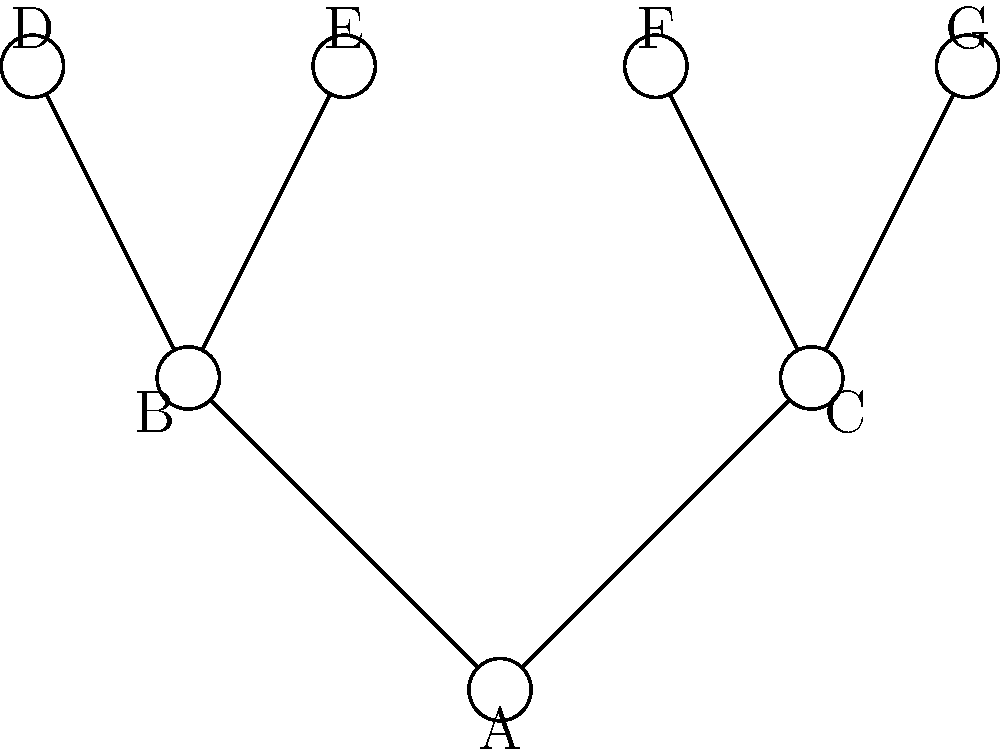In the family tree topology shown above, which represents a simplified genealogical structure, what is the total number of connected components and cycles (loops) present? To answer this question, we need to analyze the topological properties of the given family tree structure:

1. Connected Components:
   - A connected component is a subset of the graph where any two vertices are connected by a path.
   - In this family tree, all nodes (A through G) are connected to each other through edges.
   - Therefore, there is only one connected component.

2. Cycles (Loops):
   - A cycle is a path that starts and ends at the same vertex without repeating any edges.
   - In this family tree structure, there are no cycles present.
   - The tree branches out from node A to nodes B and C, and then further to nodes D, E, F, and G.
   - There are no edges connecting siblings or cousins, which would be necessary to form a cycle.

3. Calculation:
   - Number of connected components: 1
   - Number of cycles: 0
   - Total: 1 + 0 = 1

Therefore, the total number of connected components and cycles in this family tree topology is 1.
Answer: 1 